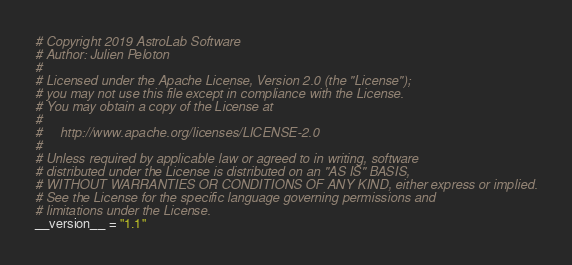Convert code to text. <code><loc_0><loc_0><loc_500><loc_500><_Python_># Copyright 2019 AstroLab Software
# Author: Julien Peloton
#
# Licensed under the Apache License, Version 2.0 (the "License");
# you may not use this file except in compliance with the License.
# You may obtain a copy of the License at
#
#     http://www.apache.org/licenses/LICENSE-2.0
#
# Unless required by applicable law or agreed to in writing, software
# distributed under the License is distributed on an "AS IS" BASIS,
# WITHOUT WARRANTIES OR CONDITIONS OF ANY KIND, either express or implied.
# See the License for the specific language governing permissions and
# limitations under the License.
__version__ = "1.1"
</code> 